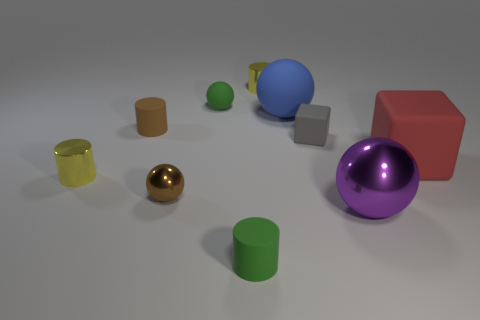There is a yellow metal thing that is to the left of the green cylinder; is it the same shape as the large blue thing?
Ensure brevity in your answer.  No. How many brown objects are either big rubber spheres or balls?
Your answer should be compact. 1. Are there more small cyan shiny objects than green balls?
Offer a terse response. No. There is a cube that is the same size as the purple object; what is its color?
Keep it short and to the point. Red. How many balls are tiny gray things or brown rubber objects?
Ensure brevity in your answer.  0. There is a big blue matte thing; is its shape the same as the green rubber object behind the big metallic object?
Make the answer very short. Yes. What number of purple metal things have the same size as the green matte cylinder?
Provide a short and direct response. 0. There is a tiny green object that is in front of the brown cylinder; does it have the same shape as the tiny shiny object to the right of the green matte cylinder?
Provide a succinct answer. Yes. What is the color of the metallic cylinder right of the tiny green object behind the brown rubber cylinder?
Give a very brief answer. Yellow. The large matte thing that is the same shape as the large purple metal thing is what color?
Make the answer very short. Blue. 